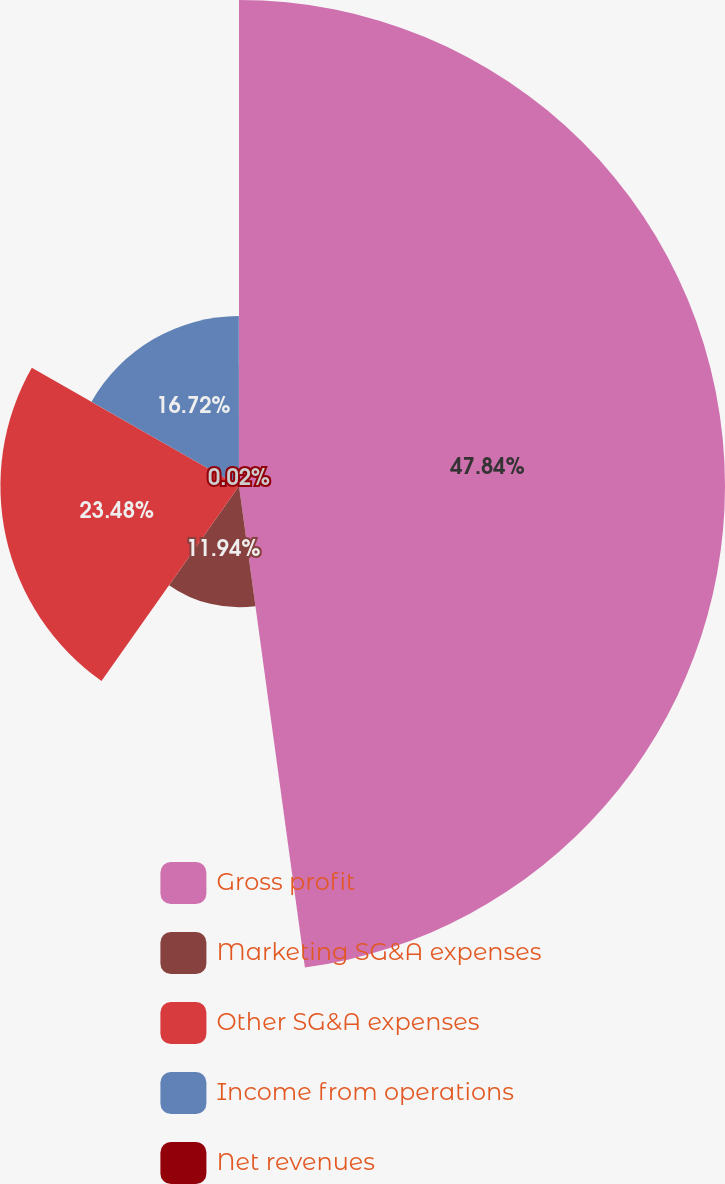Convert chart to OTSL. <chart><loc_0><loc_0><loc_500><loc_500><pie_chart><fcel>Gross profit<fcel>Marketing SG&A expenses<fcel>Other SG&A expenses<fcel>Income from operations<fcel>Net revenues<nl><fcel>47.83%<fcel>11.94%<fcel>23.48%<fcel>16.72%<fcel>0.02%<nl></chart> 